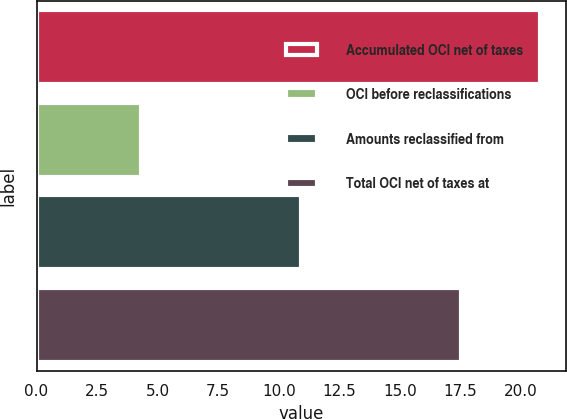Convert chart to OTSL. <chart><loc_0><loc_0><loc_500><loc_500><bar_chart><fcel>Accumulated OCI net of taxes<fcel>OCI before reclassifications<fcel>Amounts reclassified from<fcel>Total OCI net of taxes at<nl><fcel>20.8<fcel>4.3<fcel>10.9<fcel>17.5<nl></chart> 